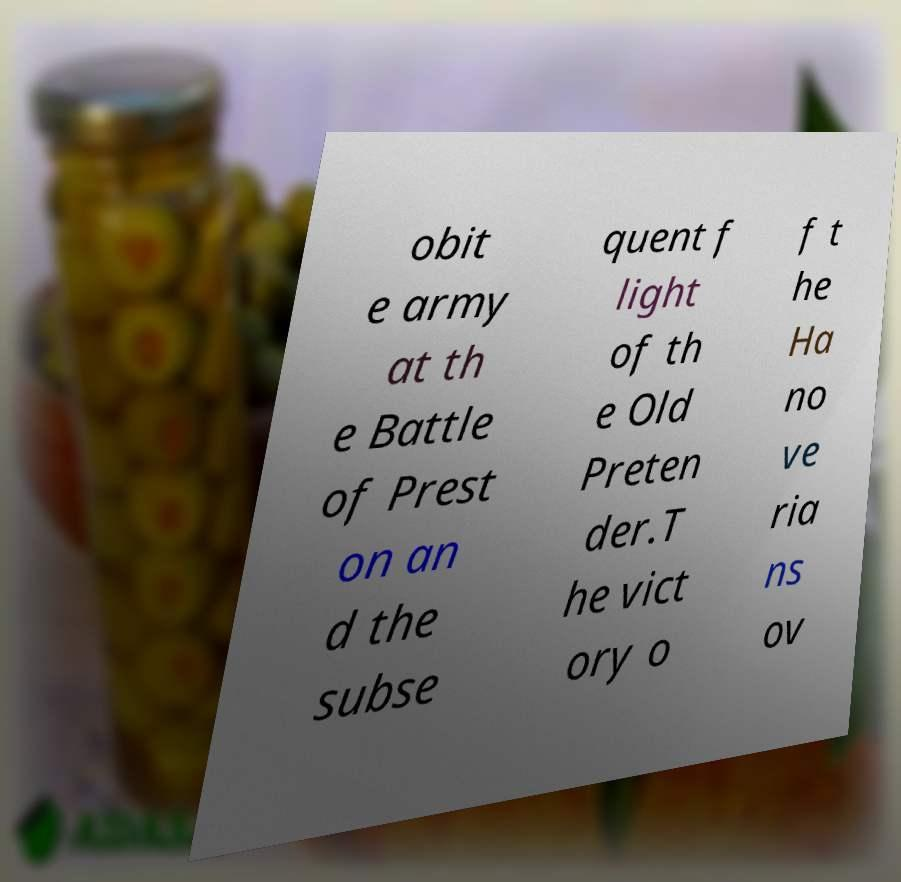Could you assist in decoding the text presented in this image and type it out clearly? obit e army at th e Battle of Prest on an d the subse quent f light of th e Old Preten der.T he vict ory o f t he Ha no ve ria ns ov 